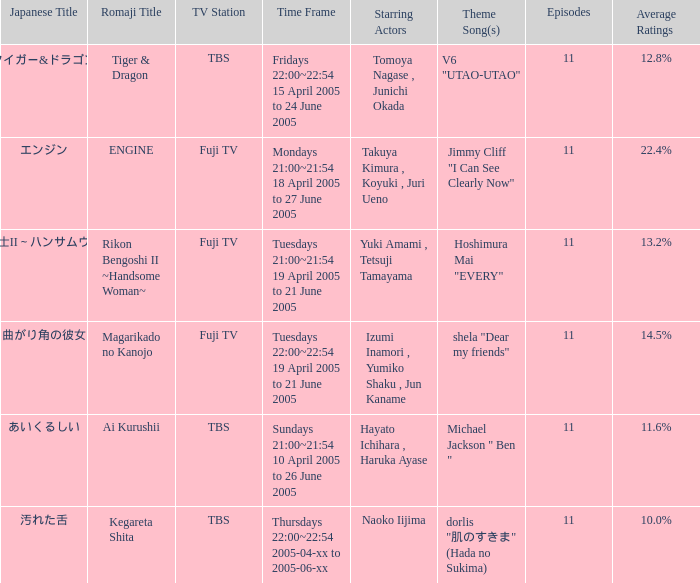What is the theme song for Magarikado no Kanojo? Shela "dear my friends". 